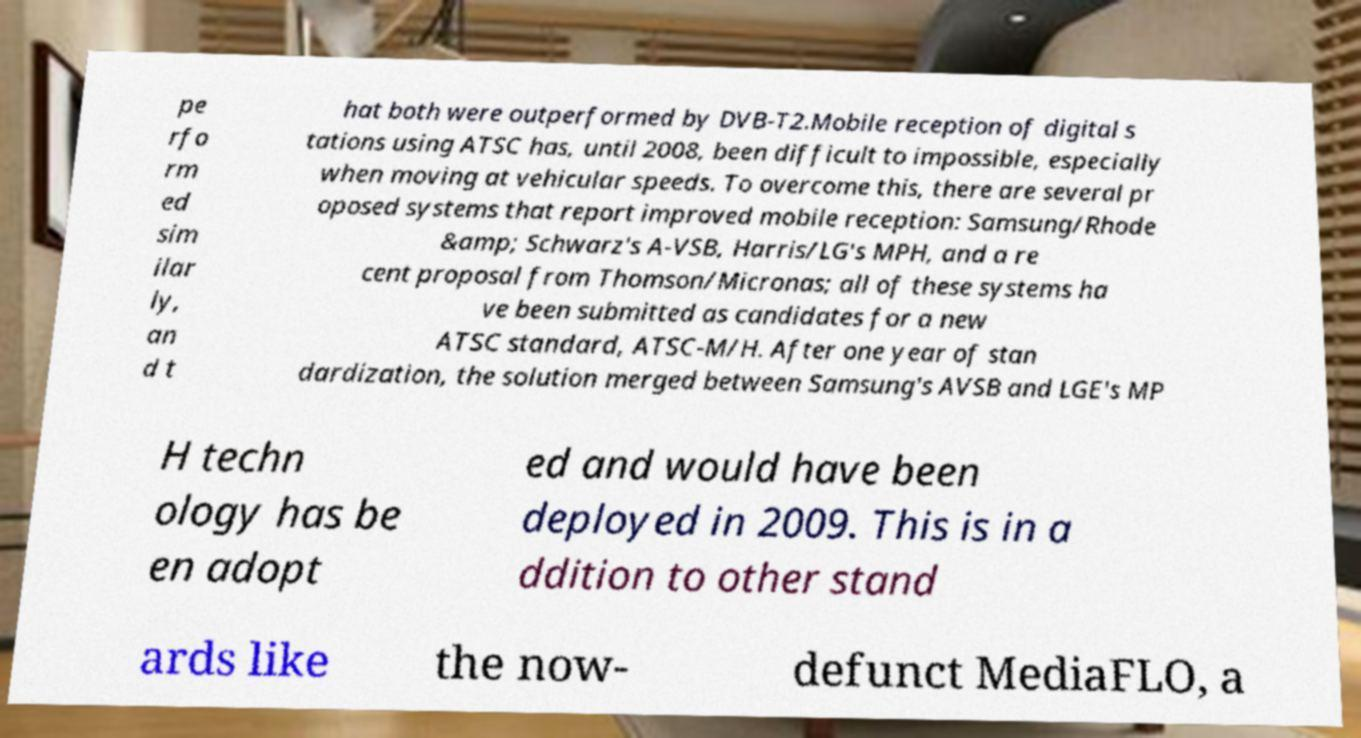What messages or text are displayed in this image? I need them in a readable, typed format. pe rfo rm ed sim ilar ly, an d t hat both were outperformed by DVB-T2.Mobile reception of digital s tations using ATSC has, until 2008, been difficult to impossible, especially when moving at vehicular speeds. To overcome this, there are several pr oposed systems that report improved mobile reception: Samsung/Rhode &amp; Schwarz's A-VSB, Harris/LG's MPH, and a re cent proposal from Thomson/Micronas; all of these systems ha ve been submitted as candidates for a new ATSC standard, ATSC-M/H. After one year of stan dardization, the solution merged between Samsung's AVSB and LGE's MP H techn ology has be en adopt ed and would have been deployed in 2009. This is in a ddition to other stand ards like the now- defunct MediaFLO, a 